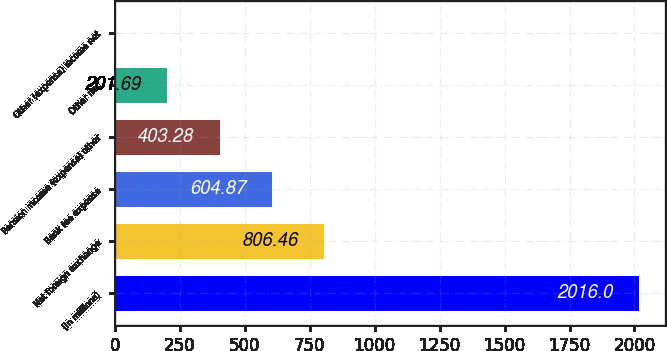Convert chart to OTSL. <chart><loc_0><loc_0><loc_500><loc_500><bar_chart><fcel>(In millions)<fcel>Net foreign exchange<fcel>Bank fee expense<fcel>Pension income (expense) other<fcel>Other net<fcel>Other (expense) income net<nl><fcel>2016<fcel>806.46<fcel>604.87<fcel>403.28<fcel>201.69<fcel>0.1<nl></chart> 